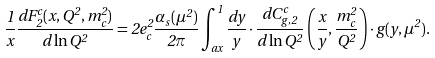Convert formula to latex. <formula><loc_0><loc_0><loc_500><loc_500>\frac { 1 } { x } \frac { d F _ { 2 } ^ { c } ( x , Q ^ { 2 } , m _ { c } ^ { 2 } ) } { d \ln { Q ^ { 2 } } } = 2 e _ { c } ^ { 2 } \frac { \alpha _ { s } ( \mu ^ { 2 } ) } { 2 \pi } \int _ { a x } ^ { 1 } \frac { d y } { y } \cdot \frac { d C _ { g , 2 } ^ { c } } { d \ln Q ^ { 2 } } \left ( \frac { x } { y } , \frac { m _ { c } ^ { 2 } } { Q ^ { 2 } } \right ) \cdot g ( y , \mu ^ { 2 } ) .</formula> 